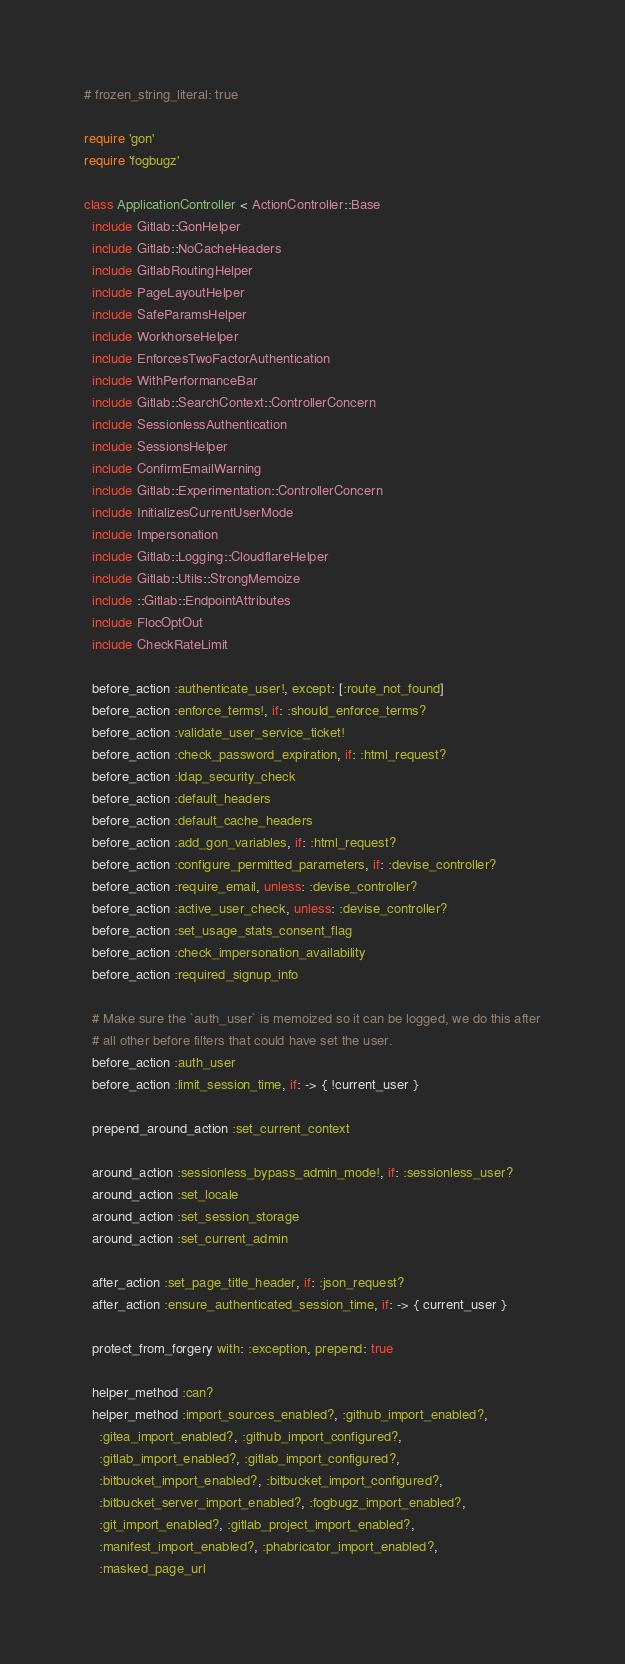Convert code to text. <code><loc_0><loc_0><loc_500><loc_500><_Ruby_># frozen_string_literal: true

require 'gon'
require 'fogbugz'

class ApplicationController < ActionController::Base
  include Gitlab::GonHelper
  include Gitlab::NoCacheHeaders
  include GitlabRoutingHelper
  include PageLayoutHelper
  include SafeParamsHelper
  include WorkhorseHelper
  include EnforcesTwoFactorAuthentication
  include WithPerformanceBar
  include Gitlab::SearchContext::ControllerConcern
  include SessionlessAuthentication
  include SessionsHelper
  include ConfirmEmailWarning
  include Gitlab::Experimentation::ControllerConcern
  include InitializesCurrentUserMode
  include Impersonation
  include Gitlab::Logging::CloudflareHelper
  include Gitlab::Utils::StrongMemoize
  include ::Gitlab::EndpointAttributes
  include FlocOptOut
  include CheckRateLimit

  before_action :authenticate_user!, except: [:route_not_found]
  before_action :enforce_terms!, if: :should_enforce_terms?
  before_action :validate_user_service_ticket!
  before_action :check_password_expiration, if: :html_request?
  before_action :ldap_security_check
  before_action :default_headers
  before_action :default_cache_headers
  before_action :add_gon_variables, if: :html_request?
  before_action :configure_permitted_parameters, if: :devise_controller?
  before_action :require_email, unless: :devise_controller?
  before_action :active_user_check, unless: :devise_controller?
  before_action :set_usage_stats_consent_flag
  before_action :check_impersonation_availability
  before_action :required_signup_info

  # Make sure the `auth_user` is memoized so it can be logged, we do this after
  # all other before filters that could have set the user.
  before_action :auth_user
  before_action :limit_session_time, if: -> { !current_user }

  prepend_around_action :set_current_context

  around_action :sessionless_bypass_admin_mode!, if: :sessionless_user?
  around_action :set_locale
  around_action :set_session_storage
  around_action :set_current_admin

  after_action :set_page_title_header, if: :json_request?
  after_action :ensure_authenticated_session_time, if: -> { current_user }

  protect_from_forgery with: :exception, prepend: true

  helper_method :can?
  helper_method :import_sources_enabled?, :github_import_enabled?,
    :gitea_import_enabled?, :github_import_configured?,
    :gitlab_import_enabled?, :gitlab_import_configured?,
    :bitbucket_import_enabled?, :bitbucket_import_configured?,
    :bitbucket_server_import_enabled?, :fogbugz_import_enabled?,
    :git_import_enabled?, :gitlab_project_import_enabled?,
    :manifest_import_enabled?, :phabricator_import_enabled?,
    :masked_page_url
</code> 